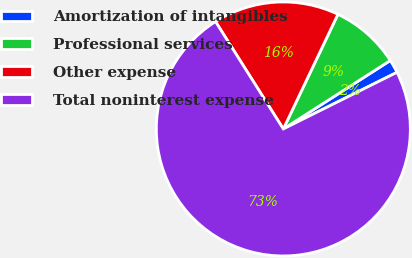<chart> <loc_0><loc_0><loc_500><loc_500><pie_chart><fcel>Amortization of intangibles<fcel>Professional services<fcel>Other expense<fcel>Total noninterest expense<nl><fcel>1.7%<fcel>8.87%<fcel>16.04%<fcel>73.4%<nl></chart> 